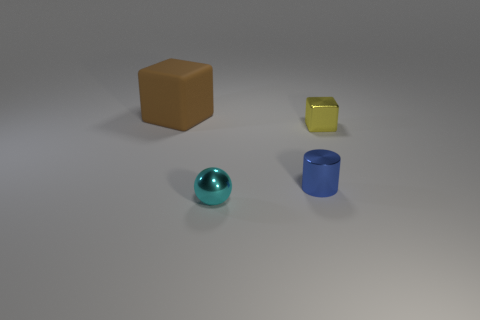How big is the ball?
Give a very brief answer. Small. Is the material of the block on the right side of the tiny sphere the same as the tiny cyan sphere?
Keep it short and to the point. Yes. What is the color of the matte object that is the same shape as the small yellow metallic thing?
Give a very brief answer. Brown. There is a cube that is in front of the brown cube; is its color the same as the cylinder?
Make the answer very short. No. Are there any small balls behind the cyan sphere?
Your answer should be very brief. No. What color is the small object that is both in front of the small cube and on the right side of the small metallic ball?
Provide a short and direct response. Blue. There is a block on the right side of the thing that is behind the yellow metal object; what is its size?
Your response must be concise. Small. What number of balls are either brown matte objects or small things?
Make the answer very short. 1. What is the color of the metal cylinder that is the same size as the metallic sphere?
Make the answer very short. Blue. What shape is the thing behind the block to the right of the tiny metallic ball?
Your response must be concise. Cube. 